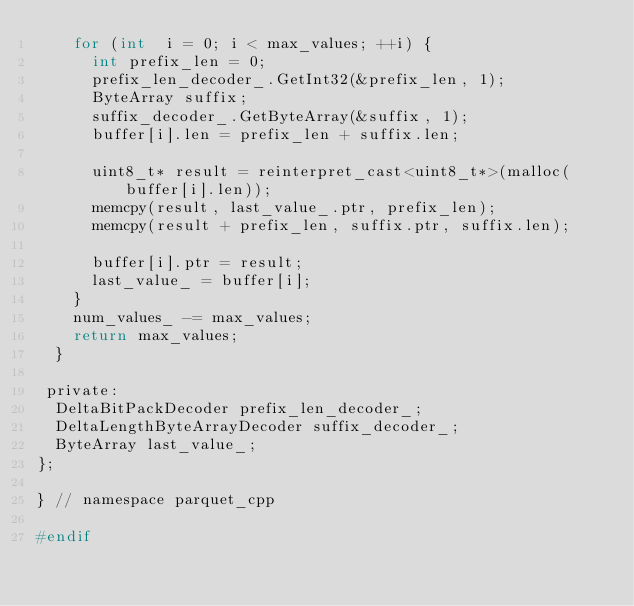Convert code to text. <code><loc_0><loc_0><loc_500><loc_500><_C_>    for (int  i = 0; i < max_values; ++i) {
      int prefix_len = 0;
      prefix_len_decoder_.GetInt32(&prefix_len, 1);
      ByteArray suffix;
      suffix_decoder_.GetByteArray(&suffix, 1);
      buffer[i].len = prefix_len + suffix.len;

      uint8_t* result = reinterpret_cast<uint8_t*>(malloc(buffer[i].len));
      memcpy(result, last_value_.ptr, prefix_len);
      memcpy(result + prefix_len, suffix.ptr, suffix.len);

      buffer[i].ptr = result;
      last_value_ = buffer[i];
    }
    num_values_ -= max_values;
    return max_values;
  }

 private:
  DeltaBitPackDecoder prefix_len_decoder_;
  DeltaLengthByteArrayDecoder suffix_decoder_;
  ByteArray last_value_;
};

} // namespace parquet_cpp

#endif
</code> 